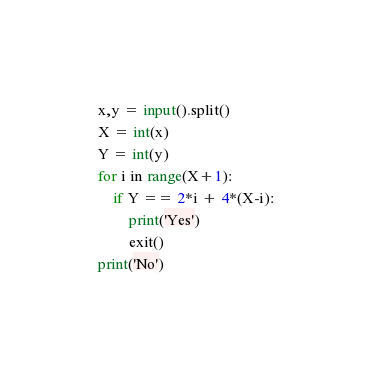<code> <loc_0><loc_0><loc_500><loc_500><_Python_>x,y = input().split()
X = int(x)
Y = int(y)
for i in range(X+1):
    if Y == 2*i + 4*(X-i):
        print('Yes')
        exit()
print('No')</code> 